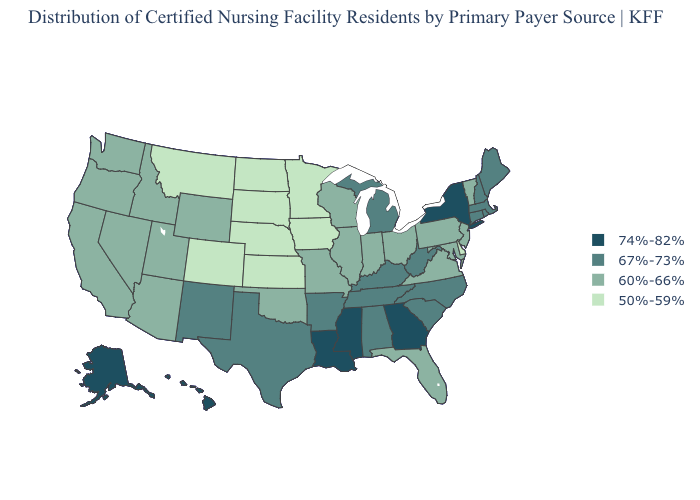Which states have the lowest value in the MidWest?
Keep it brief. Iowa, Kansas, Minnesota, Nebraska, North Dakota, South Dakota. What is the value of Arkansas?
Give a very brief answer. 67%-73%. Which states have the highest value in the USA?
Quick response, please. Alaska, Georgia, Hawaii, Louisiana, Mississippi, New York. Does the map have missing data?
Concise answer only. No. What is the highest value in the MidWest ?
Write a very short answer. 67%-73%. Does Georgia have the highest value in the USA?
Be succinct. Yes. Name the states that have a value in the range 67%-73%?
Short answer required. Alabama, Arkansas, Connecticut, Kentucky, Maine, Massachusetts, Michigan, New Hampshire, New Mexico, North Carolina, Rhode Island, South Carolina, Tennessee, Texas, West Virginia. What is the value of Indiana?
Give a very brief answer. 60%-66%. Does the map have missing data?
Answer briefly. No. Does California have the highest value in the West?
Keep it brief. No. What is the value of Nebraska?
Answer briefly. 50%-59%. What is the value of Washington?
Answer briefly. 60%-66%. What is the lowest value in the USA?
Give a very brief answer. 50%-59%. Among the states that border Utah , which have the lowest value?
Give a very brief answer. Colorado. Name the states that have a value in the range 50%-59%?
Short answer required. Colorado, Delaware, Iowa, Kansas, Minnesota, Montana, Nebraska, North Dakota, South Dakota. 